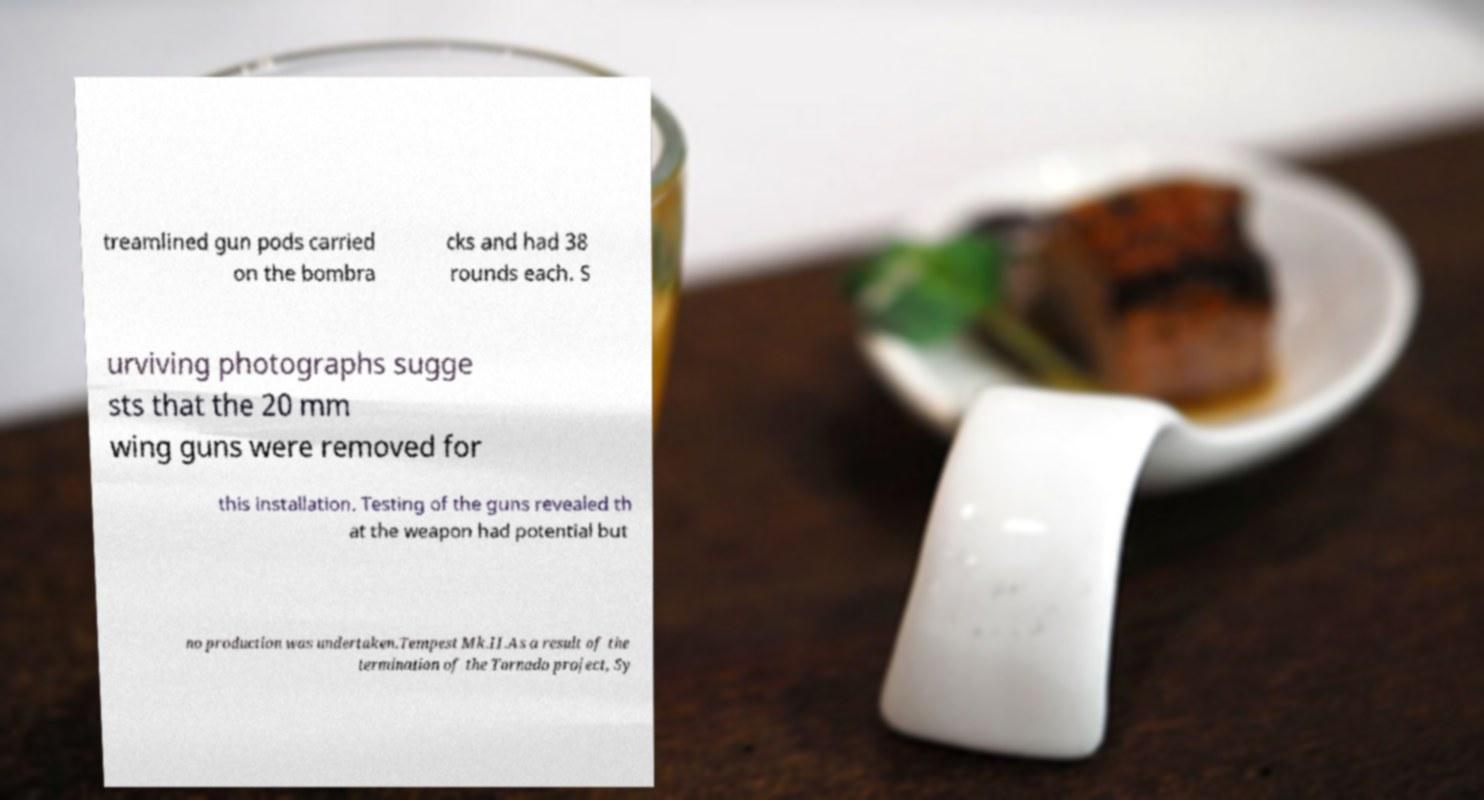Can you accurately transcribe the text from the provided image for me? treamlined gun pods carried on the bombra cks and had 38 rounds each. S urviving photographs sugge sts that the 20 mm wing guns were removed for this installation. Testing of the guns revealed th at the weapon had potential but no production was undertaken.Tempest Mk.II.As a result of the termination of the Tornado project, Sy 